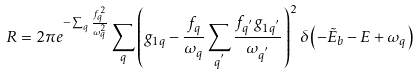Convert formula to latex. <formula><loc_0><loc_0><loc_500><loc_500>R = 2 \pi e ^ { - \sum _ { q } \frac { f _ { q } ^ { 2 } } { \omega _ { q } ^ { 2 } } } \sum _ { q } \left ( g _ { 1 q } - \frac { f _ { q } } { \omega _ { q } } \sum _ { q ^ { ^ { \prime } } } \frac { f _ { q ^ { ^ { \prime } } } g _ { 1 q ^ { ^ { \prime } } } } { \omega _ { q ^ { ^ { \prime } } } } \right ) ^ { 2 } \delta \left ( - \tilde { E } _ { b } - E + \omega _ { q } \right )</formula> 